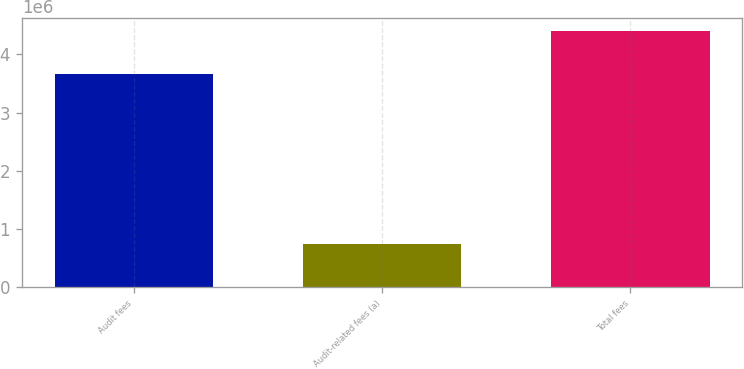<chart> <loc_0><loc_0><loc_500><loc_500><bar_chart><fcel>Audit fees<fcel>Audit-related fees (a)<fcel>Total fees<nl><fcel>3.66479e+06<fcel>739834<fcel>4.40463e+06<nl></chart> 